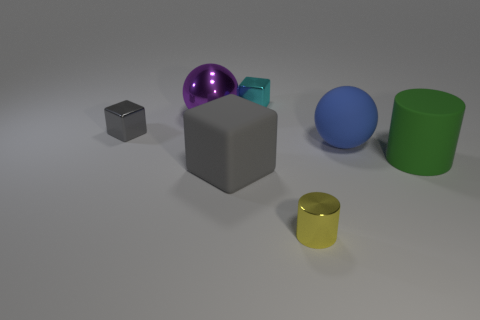Add 1 small matte objects. How many objects exist? 8 Subtract all spheres. How many objects are left? 5 Add 5 blue spheres. How many blue spheres are left? 6 Add 4 purple metallic balls. How many purple metallic balls exist? 5 Subtract 1 yellow cylinders. How many objects are left? 6 Subtract all tiny shiny cylinders. Subtract all large matte cylinders. How many objects are left? 5 